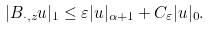Convert formula to latex. <formula><loc_0><loc_0><loc_500><loc_500>| B _ { \cdot , z } u | _ { 1 } \leq \varepsilon | u | _ { \alpha + 1 } + C _ { \varepsilon } | u | _ { 0 } .</formula> 